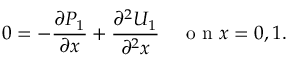<formula> <loc_0><loc_0><loc_500><loc_500>0 = - \frac { \partial P _ { 1 } } { \partial x } + \frac { \partial ^ { 2 } U _ { 1 } } { \partial ^ { 2 } x } \quad o n x = 0 , 1 .</formula> 